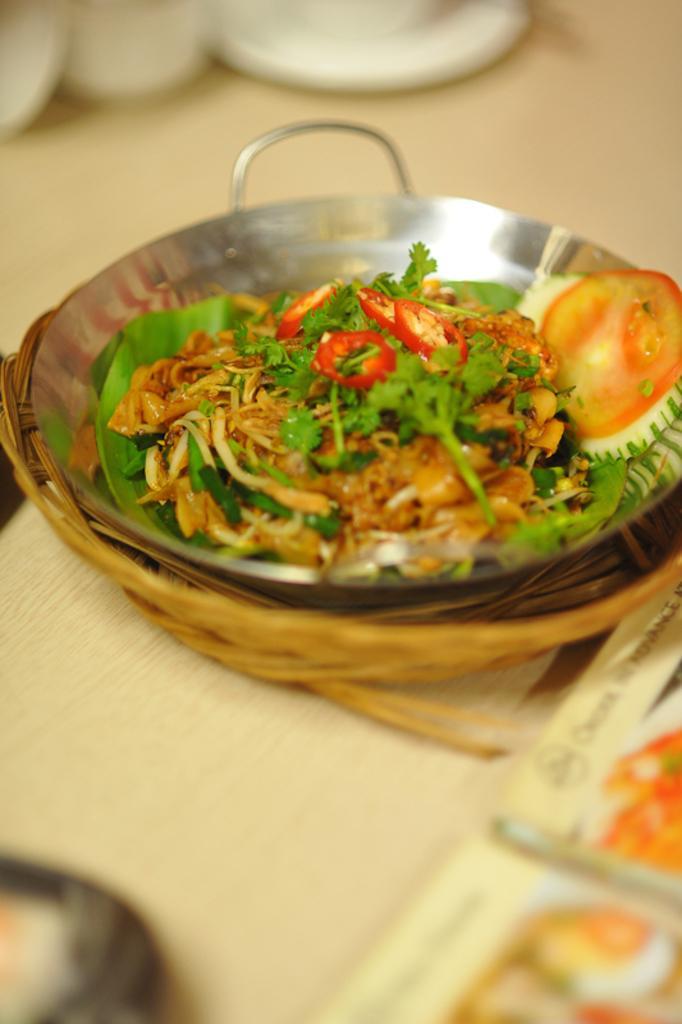Can you describe this image briefly? In this image I can see a food is in steel bowl. Bowl is in basket. Basket is in wooden board. Food is in white,brown,green and red color. 